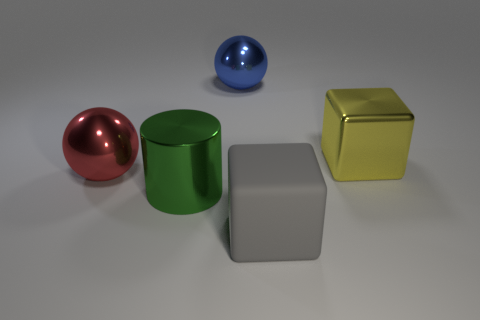How many other shiny cylinders have the same color as the cylinder?
Provide a short and direct response. 0. There is a yellow shiny object behind the matte object; is it the same shape as the gray rubber thing?
Your answer should be compact. Yes. Is the number of red metal balls that are behind the big red object less than the number of big blue spheres that are left of the big gray matte cube?
Provide a succinct answer. Yes. There is a yellow thing that is behind the gray object; what material is it?
Your answer should be very brief. Metal. Are there any purple shiny balls that have the same size as the yellow block?
Provide a short and direct response. No. There is a red thing; is its shape the same as the large metallic object to the right of the large gray matte thing?
Make the answer very short. No. There is a shiny object that is behind the big yellow shiny block; is it the same size as the block that is in front of the large yellow cube?
Keep it short and to the point. Yes. What number of other things are there of the same shape as the large blue thing?
Keep it short and to the point. 1. What is the material of the large ball that is on the left side of the blue sphere behind the yellow thing?
Provide a succinct answer. Metal. How many metallic objects are either brown cylinders or large gray objects?
Ensure brevity in your answer.  0. 